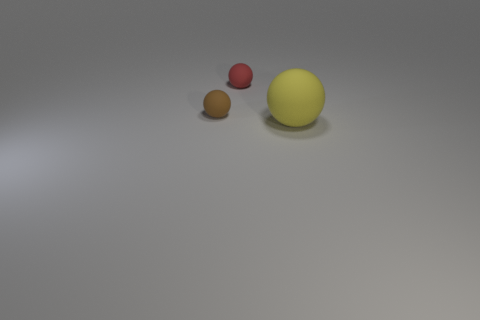There is a tiny red ball; are there any small objects in front of it? yes 